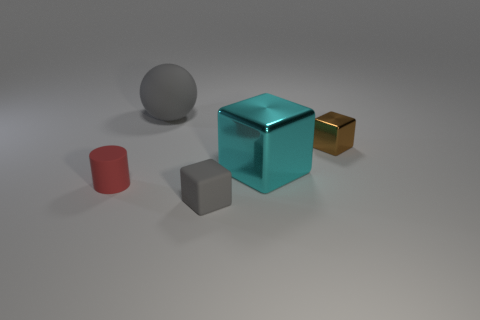Add 4 tiny red matte cylinders. How many objects exist? 9 Subtract all cylinders. How many objects are left? 4 Subtract 0 cyan balls. How many objects are left? 5 Subtract all tiny balls. Subtract all small blocks. How many objects are left? 3 Add 1 metallic cubes. How many metallic cubes are left? 3 Add 2 balls. How many balls exist? 3 